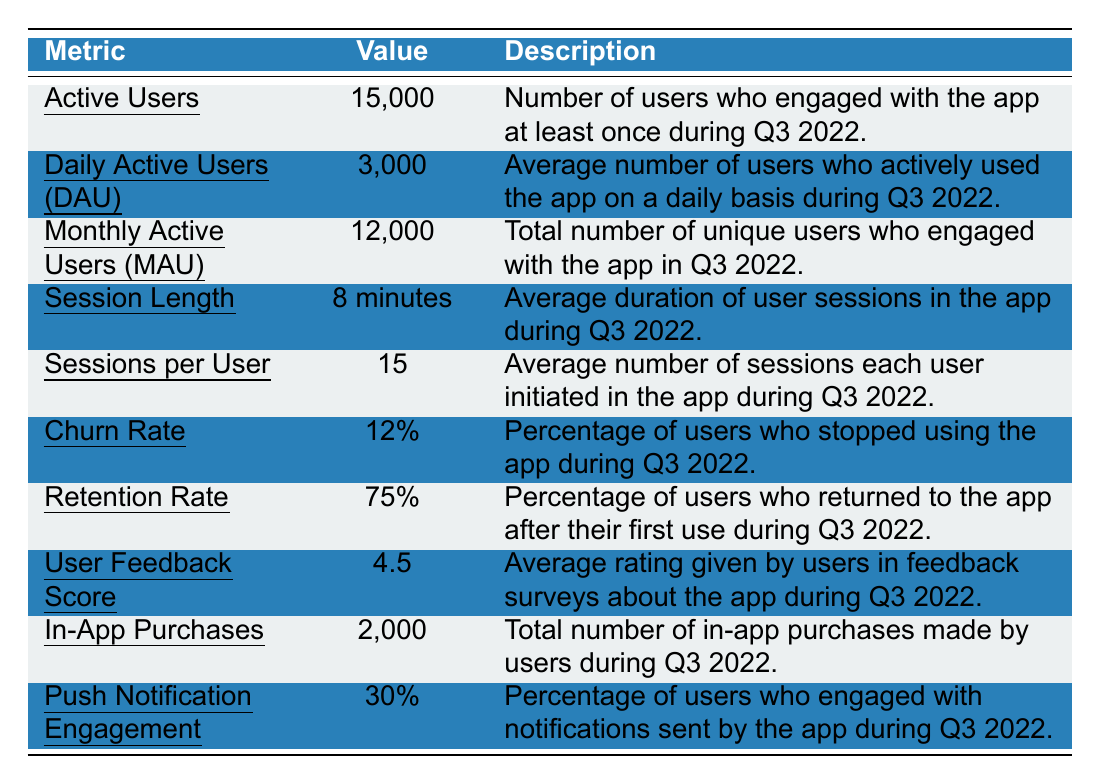What is the value for Active Users? The table clearly states that the number of Active Users is 15,000.
Answer: 15,000 What is the Monthly Active Users (MAU) figure? According to the table, the Monthly Active Users is listed as 12,000.
Answer: 12,000 What percentage of users engaged with Push Notifications? The table indicates that 30% of users engaged with notifications sent by the app.
Answer: 30% What is the average Session Length? Referring to the table, the average Session Length is mentioned as 8 minutes.
Answer: 8 minutes What is the average Daily Active Users (DAU)? The table presents an average Daily Active Users (DAU) value of 3,000.
Answer: 3,000 How many in-app purchases were made during Q3 2022? According to the table, there were 2,000 in-app purchases made by users during this period.
Answer: 2,000 What is the Churn Rate? The Churn Rate according to the table is stated as 12%.
Answer: 12% What is the Retention Rate? The Retention Rate provided in the table is 75%.
Answer: 75% What is the average number of Sessions per User? The table specifies that the average number of Sessions per User is 15.
Answer: 15 Did the app have more Active Users or Monthly Active Users (MAU)? The table shows 15,000 Active Users and 12,000 Monthly Active Users (MAU). Thus, there are more Active Users.
Answer: Yes, it had more Active Users What proportion of users returned to the app after their first use? The Retention Rate in the table indicates that 75% of users returned after their first use.
Answer: 75% How does the number of Daily Active Users compare to Monthly Active Users? The table shows 3,000 Daily Active Users compared to 12,000 Monthly Active Users. This indicates that DAU is significantly lower than MAU, implying users are not using the app daily.
Answer: DAU is lower than MAU If the average Session Length is 8 minutes and Sessions per User is 15, what is the total session time for an average user? The total session time for an average user can be calculated by multiplying Session Length (8 minutes) by Sessions per User (15). This results in 8 * 15 = 120 minutes.
Answer: 120 minutes If 12% of users churned and there were 15,000 Active Users, how many users stopped using the app in Q3 2022? To find this, calculate 12% of 15,000. This is 15,000 * 0.12 = 1,800 users.
Answer: 1,800 users If the User Feedback Score is 4.5 and is rated out of 5, is this considered a positive rating? A score of 4.5 out of 5 is generally considered a positive rating.
Answer: Yes, it is positive How many users did not return after their first use, assuming a Retention Rate of 75%? If 75% returned, 100% - 75% = 25% did not return. Since there were 15,000 Active Users, users who did not return are calculated as 15,000 * 0.25 = 3,750 users.
Answer: 3,750 users 